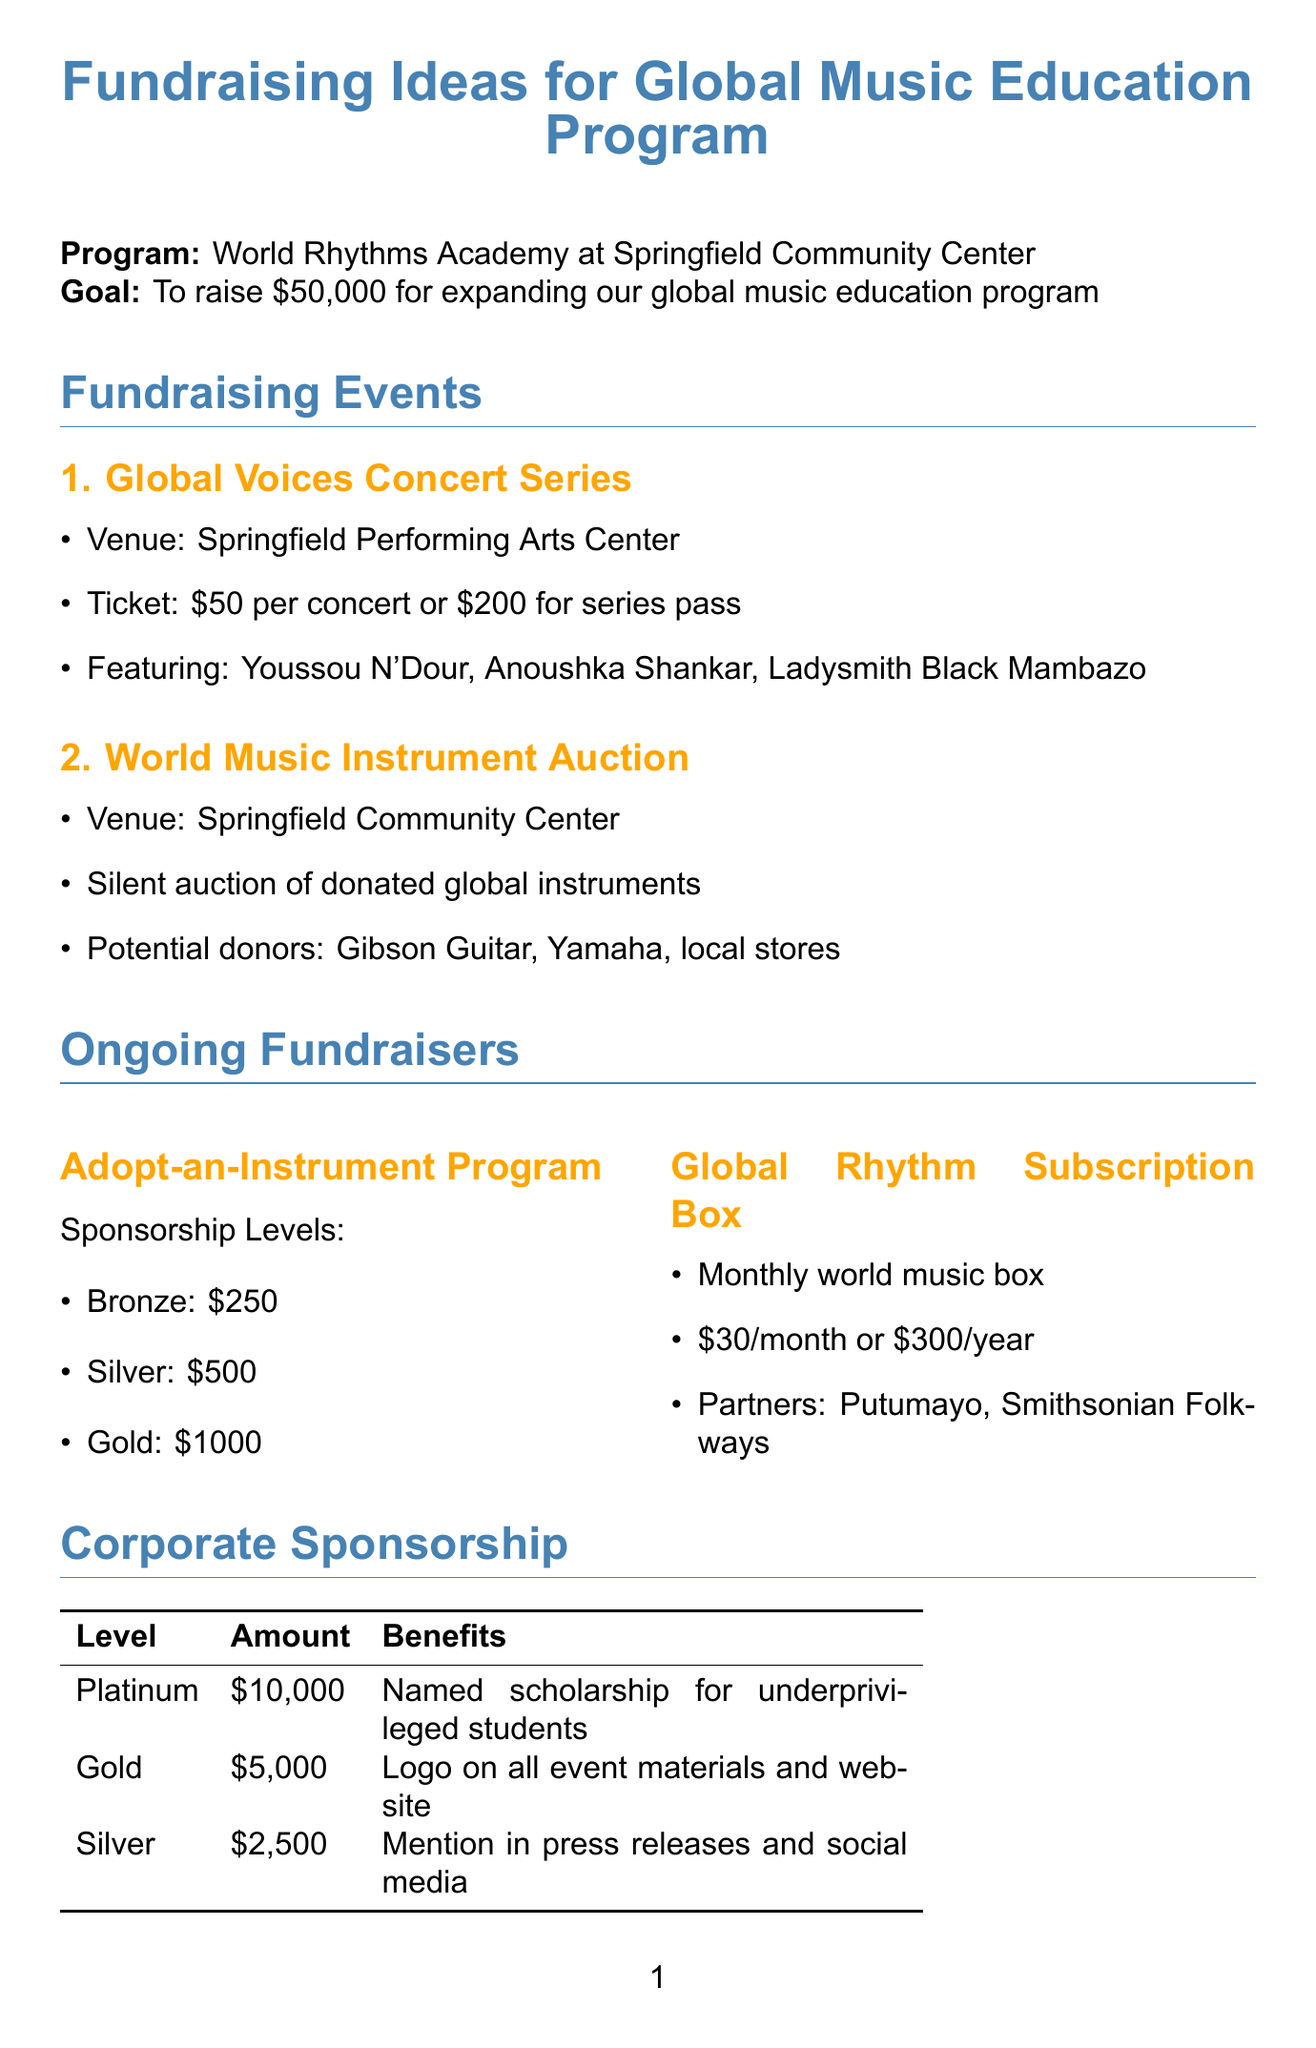What is the goal amount for fundraising? The goal amount is specified in the introduction of the memo as a target for fundraising.
Answer: $50,000 Who is the program director? The program director's name is provided in the conclusion section of the memo.
Answer: Emily Rodriguez What is one of the potential artists for the Global Voices Concert Series? The document lists several artists who might perform in the concert series.
Answer: Youssou N'Dour What is the ticket price for a single concert? The ticket price for a single concert is mentioned in the fundraising events section.
Answer: $50 What is the application deadline for the Grammy Museum Grant Program? The application deadline is noted under the grant opportunities section of the memo.
Answer: October 1, 2023 How much does the Global Rhythm Subscription Box cost per month? The cost for the subscription box is outlined in the ongoing fundraisers section.
Answer: $30 Which company is listed as a target for corporate sponsorship? The document provides a list of companies targeted for sponsorship in the corporate sponsorship section.
Answer: Apple Music What is the highest sponsorship level and its amount? The document specifies different sponsorship levels and their corresponding amounts.
Answer: Platinum, $10,000 What type of program is the Adopt-an-Instrument Program? The type of ongoing fundraiser is explained in the ongoing fundraisers section, reflecting its purpose.
Answer: Instrument adoption 